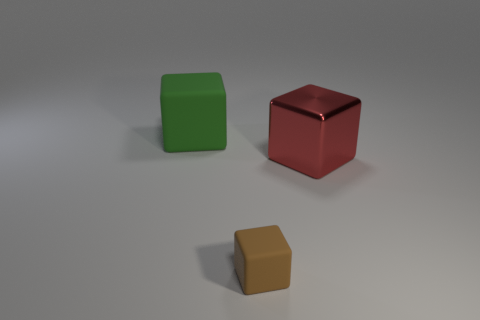Subtract all big blocks. How many blocks are left? 1 Add 3 large red cubes. How many objects exist? 6 Subtract 3 cubes. How many cubes are left? 0 Add 3 small brown blocks. How many small brown blocks exist? 4 Subtract all brown blocks. How many blocks are left? 2 Subtract 0 blue cylinders. How many objects are left? 3 Subtract all gray cubes. Subtract all gray cylinders. How many cubes are left? 3 Subtract all green rubber cubes. Subtract all large gray metallic objects. How many objects are left? 2 Add 1 large red metal cubes. How many large red metal cubes are left? 2 